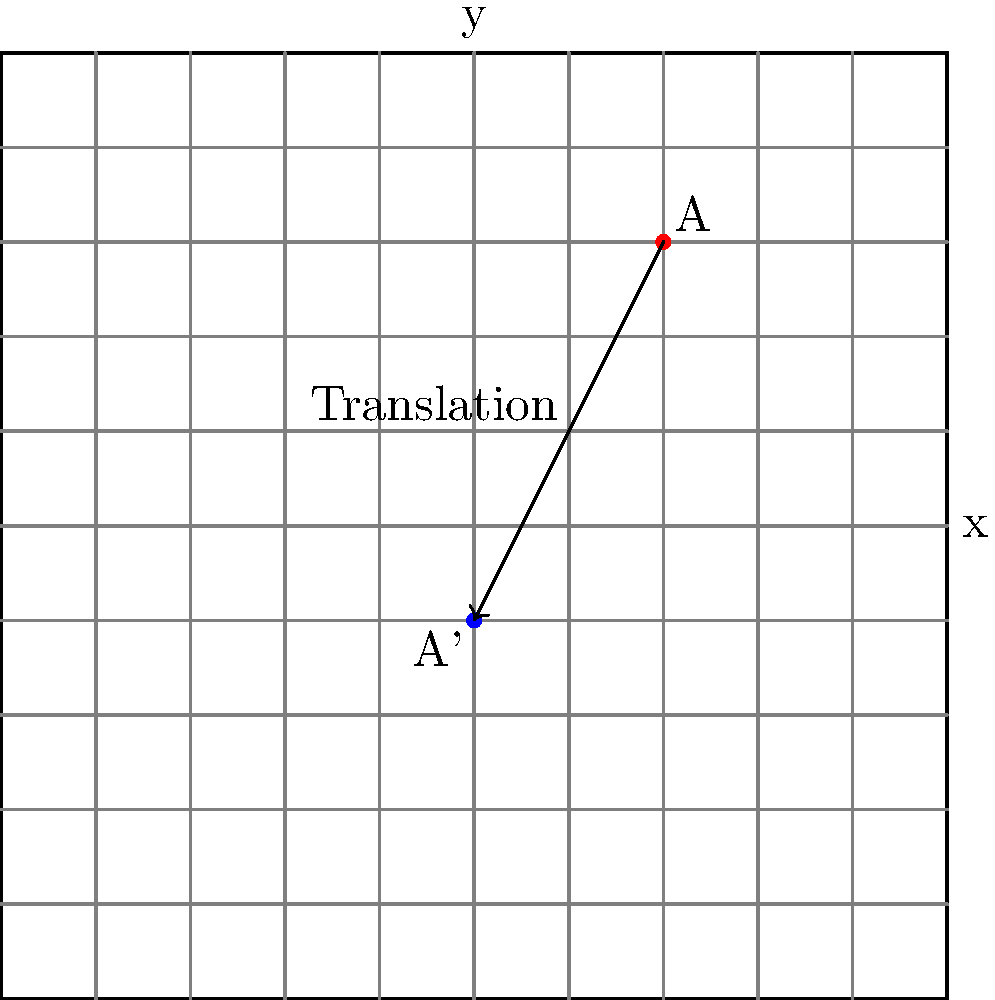During a photoshoot, you need to reposition a key light. The light's initial position is at point A(2,3) on the coordinate plane. You want to translate it to the new position A'(0,-1). What is the translation vector that describes this movement? To find the translation vector, we need to follow these steps:

1. Identify the initial and final positions:
   Initial position A: (2,3)
   Final position A': (0,-1)

2. Calculate the change in x-coordinate:
   $\Delta x = x_{final} - x_{initial} = 0 - 2 = -2$

3. Calculate the change in y-coordinate:
   $\Delta y = y_{final} - y_{initial} = -1 - 3 = -4$

4. Express the translation vector:
   The translation vector is represented as $\langle \Delta x, \Delta y \rangle$

Therefore, the translation vector that moves the lighting equipment from A(2,3) to A'(0,-1) is $\langle -2, -4 \rangle$.
Answer: $\langle -2, -4 \rangle$ 